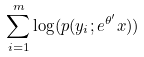<formula> <loc_0><loc_0><loc_500><loc_500>\sum _ { i = 1 } ^ { m } \log ( p ( y _ { i } ; e ^ { \theta ^ { \prime } } x ) )</formula> 